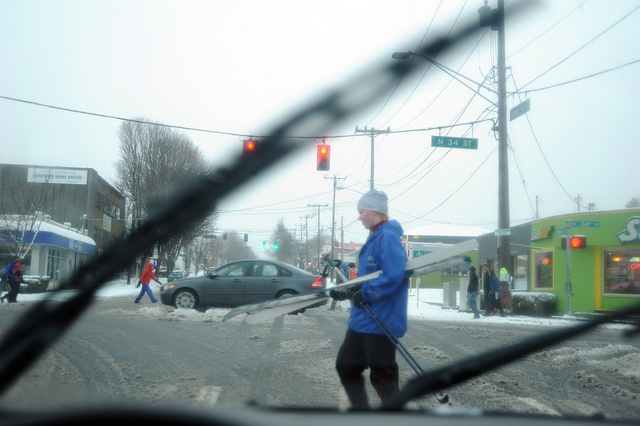Describe the objects in this image and their specific colors. I can see people in lightblue, black, blue, navy, and darkgray tones, car in lightblue, teal, purple, gray, and black tones, skis in lightblue, darkgray, and gray tones, people in lightblue, blue, gray, black, and darkblue tones, and people in lightblue, blue, brown, and gray tones in this image. 